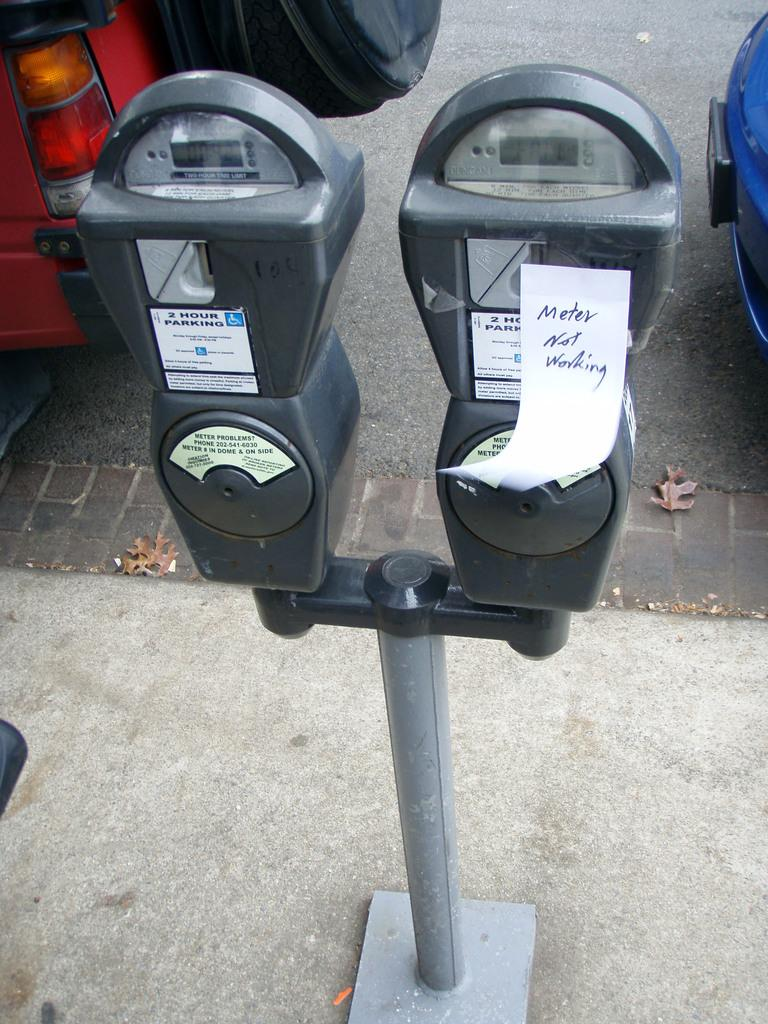<image>
Relay a brief, clear account of the picture shown. Two parking meters side by side, but only the right one has a note that says meter not working on it. 